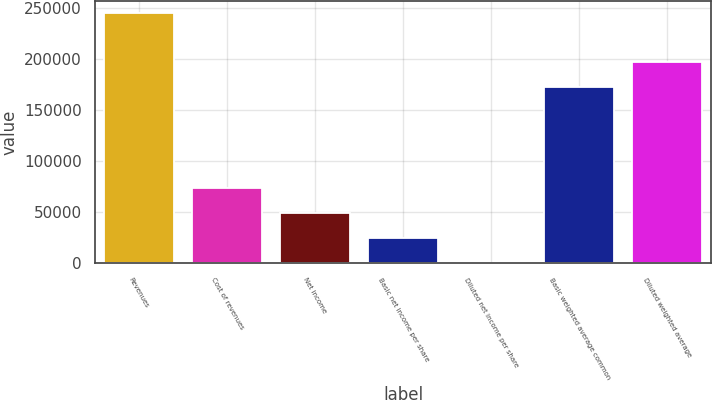Convert chart. <chart><loc_0><loc_0><loc_500><loc_500><bar_chart><fcel>Revenues<fcel>Cost of revenues<fcel>Net income<fcel>Basic net income per share<fcel>Diluted net income per share<fcel>Basic weighted average common<fcel>Diluted weighted average<nl><fcel>245318<fcel>73595.5<fcel>49063.8<fcel>24532<fcel>0.2<fcel>173317<fcel>197849<nl></chart> 